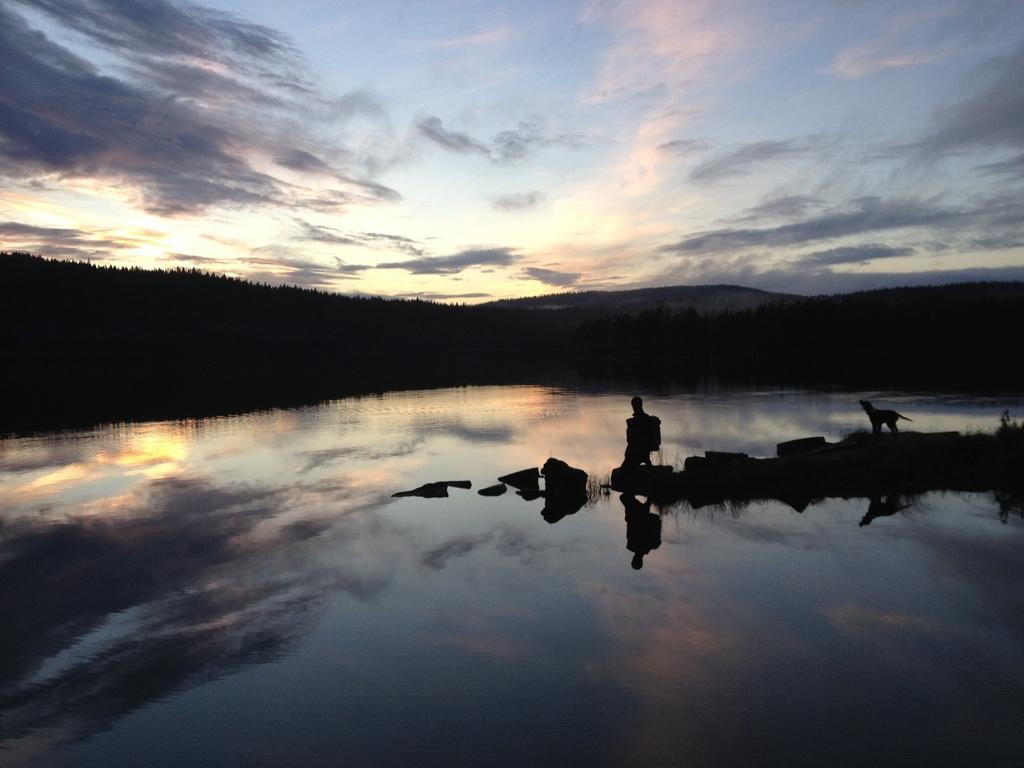Could you give a brief overview of what you see in this image? In the picture we can see water and on the water we can see some rocks with a person and a dog standing on it and in the background we can see trees on the hills and a sky with clouds. 